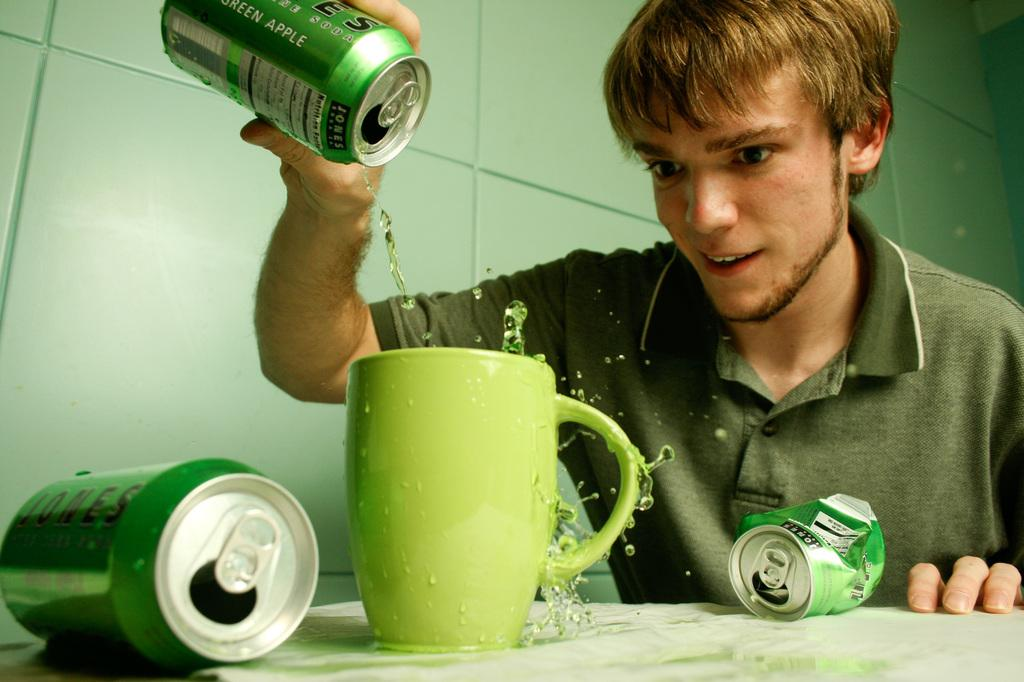Who is present in the image? There is a person in the image. What is the person doing? The person is holding a can and pouring a drink into a cup. How many cans are on the table? There are two other cans on the table. What can be seen in the background of the image? There is a wall visible in the image. What type of music is playing in the background of the image? There is no indication of music playing in the image; it only shows a person pouring a drink into a cup and other cans on the table. Are there any fowl visible in the image? No, there are no fowl present in the image. 